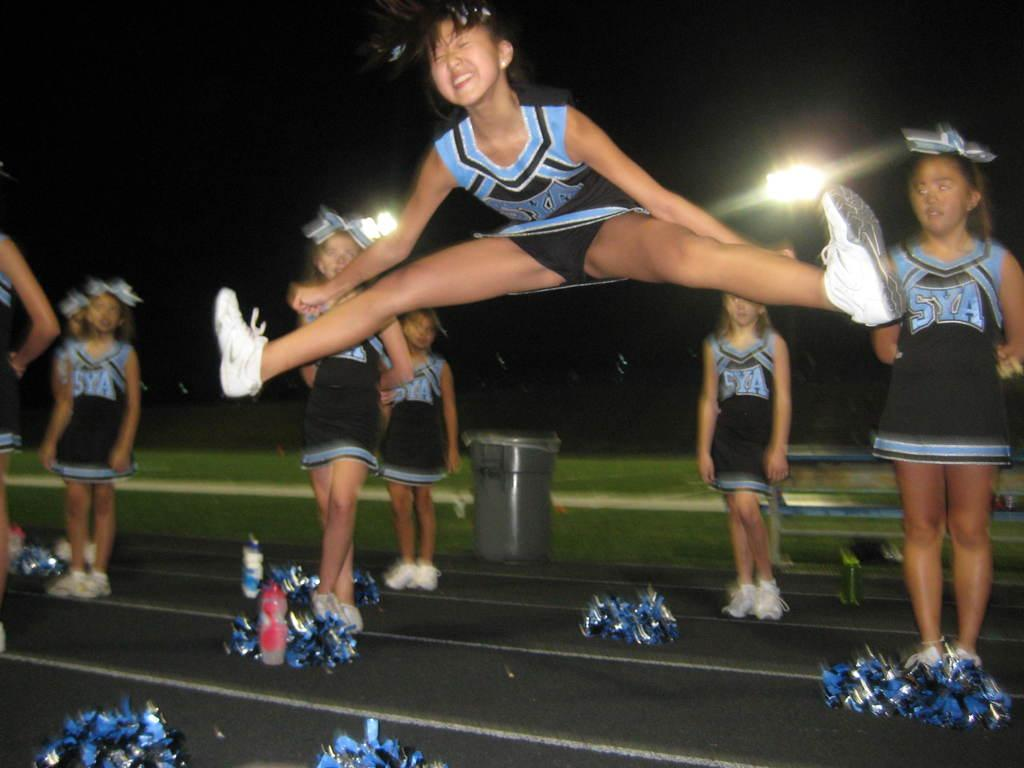What is the main subject of the image? The main subject of the image is a group of girls. Where are the girls located in the image? The girls are standing on a path in the image. What is the first girl doing in the image? The first girl is jumping by stretching her legs. What type of exchange is happening between the girls in the image? There is no exchange happening between the girls in the image; they are simply standing on a path. What is the stomach of the first girl doing in the image? The stomach of the first girl is not mentioned in the image, as the focus is on her legs while jumping. 